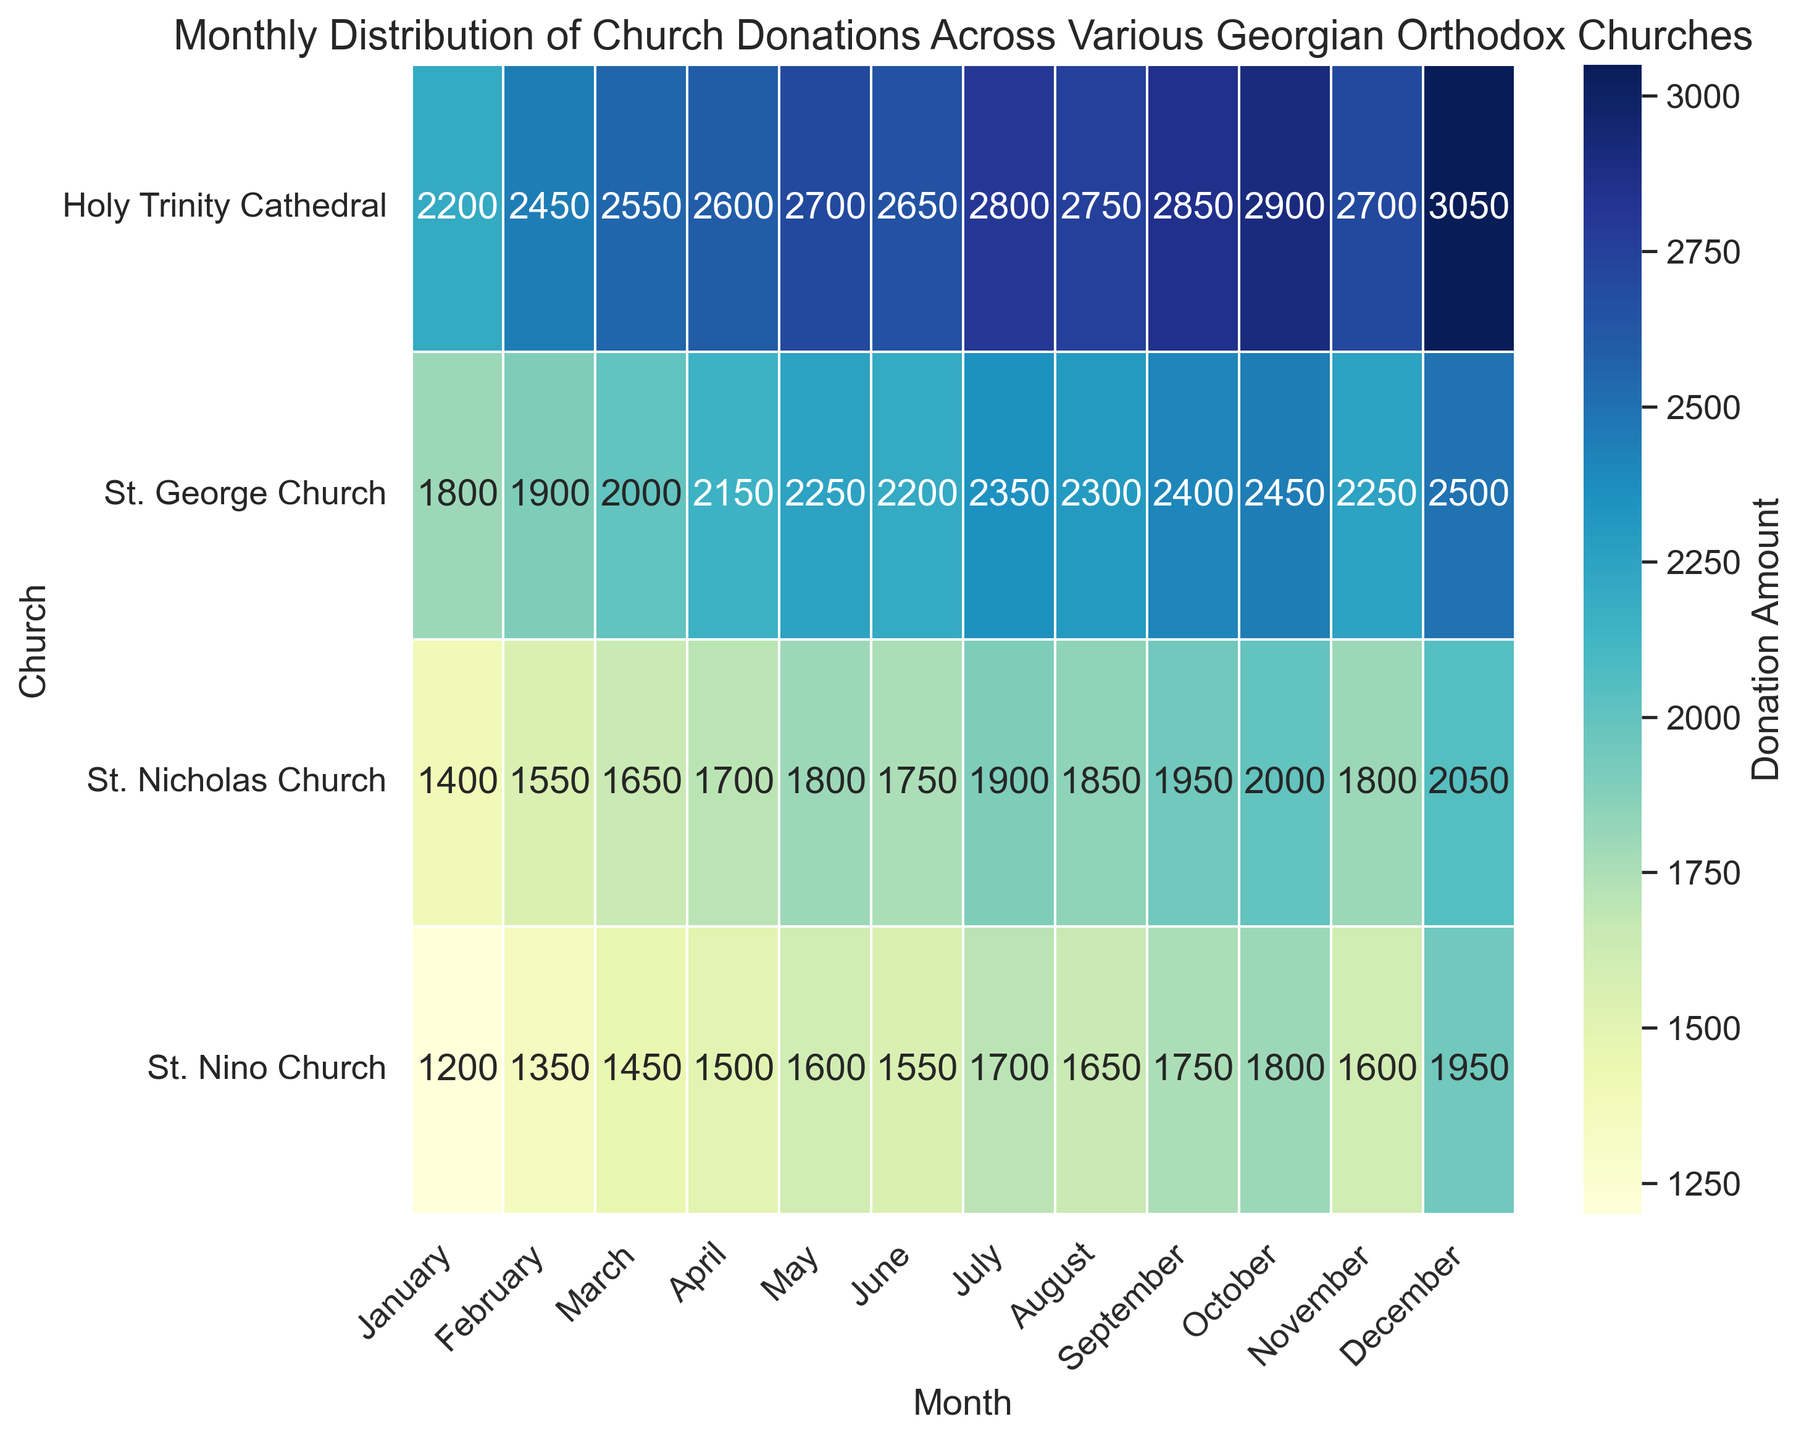What is the total donation amount for Holy Trinity Cathedral in the first quarter (January, February, and March)? To find the total donation amount for Holy Trinity Cathedral in the first quarter, sum the monthly donations for January, February, and March. The donations are 2200 (January) + 2450 (February) + 2550 (March) = 7200.
Answer: 7200 Which church received the highest single-month donation and in which month? To determine which church received the highest single-month donation, identify the highest value in the heatmap. The highest donation is 3050, received by Holy Trinity Cathedral in December.
Answer: Holy Trinity Cathedral, December Which month had the highest average donation across all churches? Calculate the average donation for each month across all churches. The sum of donations for each month divided by the number of churches gives the average, where October has the highest average: (1800 + 2450 + 2900 + 2000) / 4 = 2287.5.
Answer: October How does the donation pattern of St. Nino Church in the summer months (June, July, and August) compare to St. Nicholas Church in the same months? For St. Nino Church, sum the donations for June, July, and August: 1550 + 1700 + 1650 = 4900. For St. Nicholas Church, sum the donations for June, July, and August: 1750 + 1900 + 1850 = 5500. The total summer donation for St. Nicholas Church is higher.
Answer: St. Nicholas Church received higher donations in summer months What is the difference between the highest and lowest monthly donations received by St. George Church? Identify the highest and lowest monthly donations for St. George Church in the heatmap. The highest is 2500 (December) and the lowest is 1800 (January). The difference is 2500 - 1800 = 700.
Answer: 700 Which church had the most consistent donations throughout the year, showing the least variability? Look for the church with the smallest range (difference between the highest and lowest donations). St. Nino Church has donations between 1200 and 1950, yielding a range of 750, making it the most consistent.
Answer: St. Nino Church 